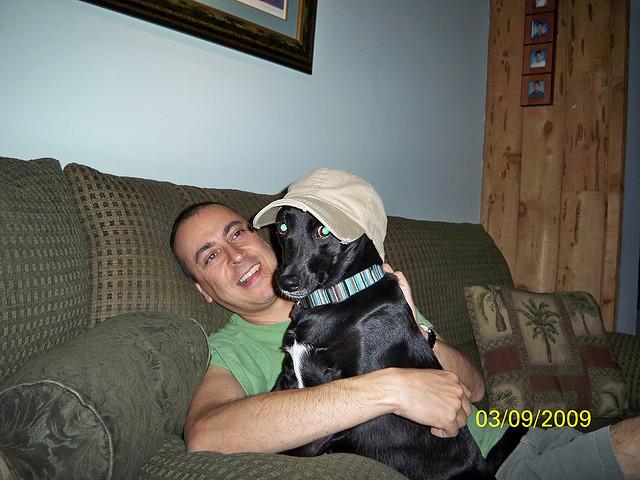What animal is this?
Keep it brief. Dog. Is this dog a big dog?
Be succinct. Yes. Is the dog sleeping?
Give a very brief answer. No. Is there a bandage on his hand?
Answer briefly. No. Is this man needing to shave?
Short answer required. No. What is this man's hairstyle called?
Short answer required. Short. What is the dog doing?
Concise answer only. Sitting. Is this a domestic or wild animal?
Quick response, please. Domestic. What does the dog have?
Give a very brief answer. Hat. What kind of dog is this?
Be succinct. Lab. What type of animal?
Short answer required. Dog. What color is the dog's collar?
Answer briefly. Blue. Are the dog and person interacting?
Write a very short answer. Yes. What is the man holding on his lap?
Answer briefly. Dog. What is the animal wearing around its neck?
Quick response, please. Collar. Is somebody packing for a trip?
Keep it brief. No. What type of puppy is the man holding?
Be succinct. Lab. When was this taken?
Keep it brief. 03/09/2009. What are they doing to the dog?
Concise answer only. Hugging. What is on the dog's head?
Answer briefly. Hat. 